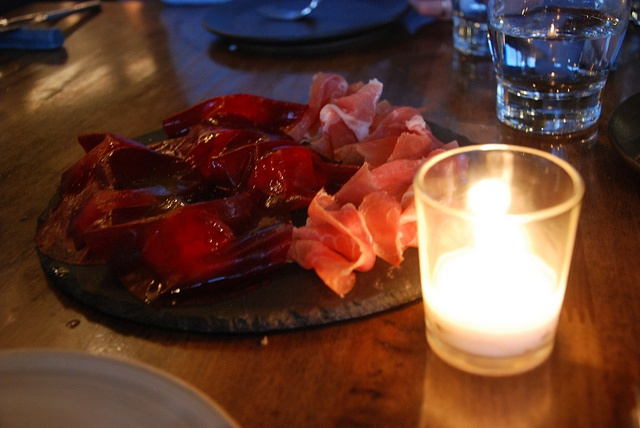Describe the objects in this image and their specific colors. I can see dining table in maroon, black, ivory, and brown tones, cup in black, ivory, tan, and brown tones, cup in black, navy, and gray tones, cup in black, navy, and gray tones, and spoon in black, navy, blue, darkgray, and darkblue tones in this image. 